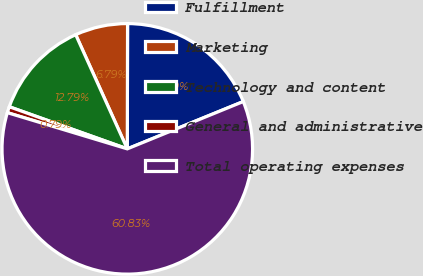Convert chart. <chart><loc_0><loc_0><loc_500><loc_500><pie_chart><fcel>Fulfillment<fcel>Marketing<fcel>Technology and content<fcel>General and administrative<fcel>Total operating expenses<nl><fcel>18.8%<fcel>6.79%<fcel>12.79%<fcel>0.79%<fcel>60.83%<nl></chart> 